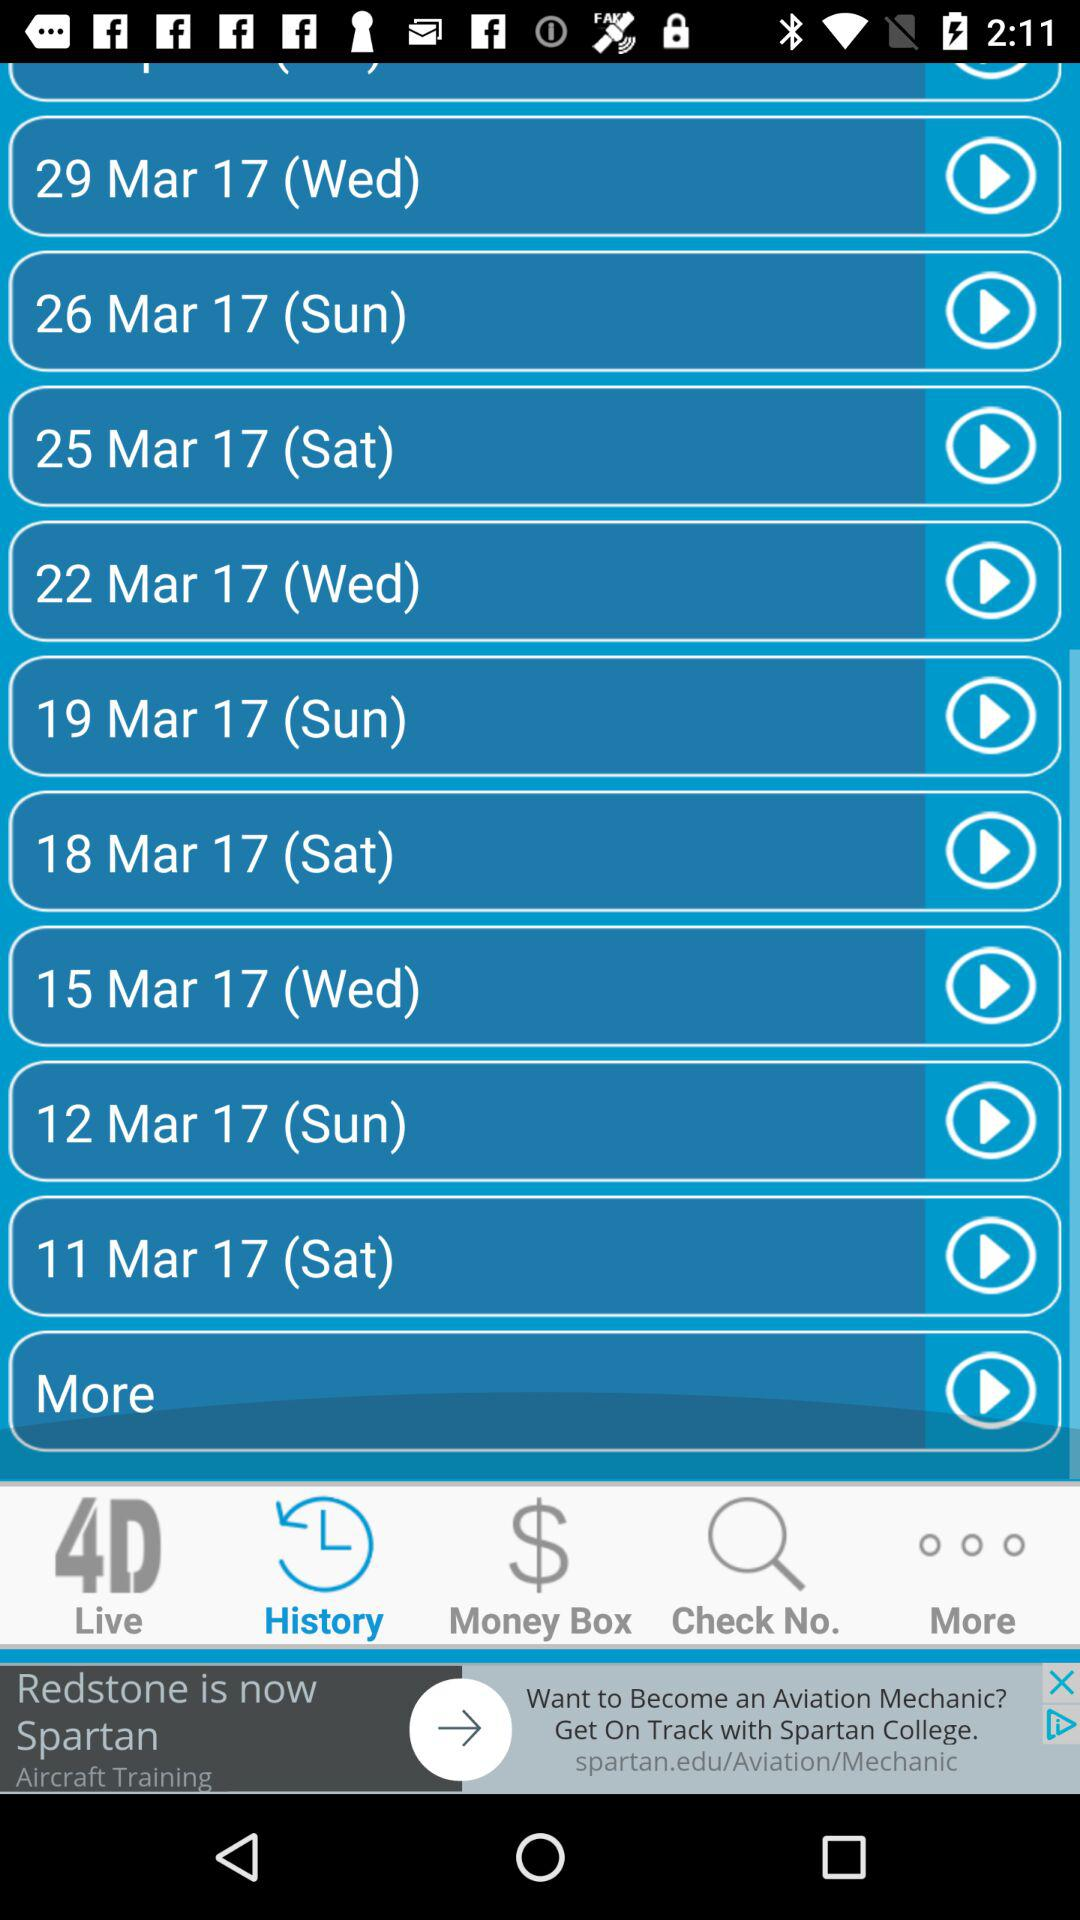Which tab is selected? The selected tab is "History". 